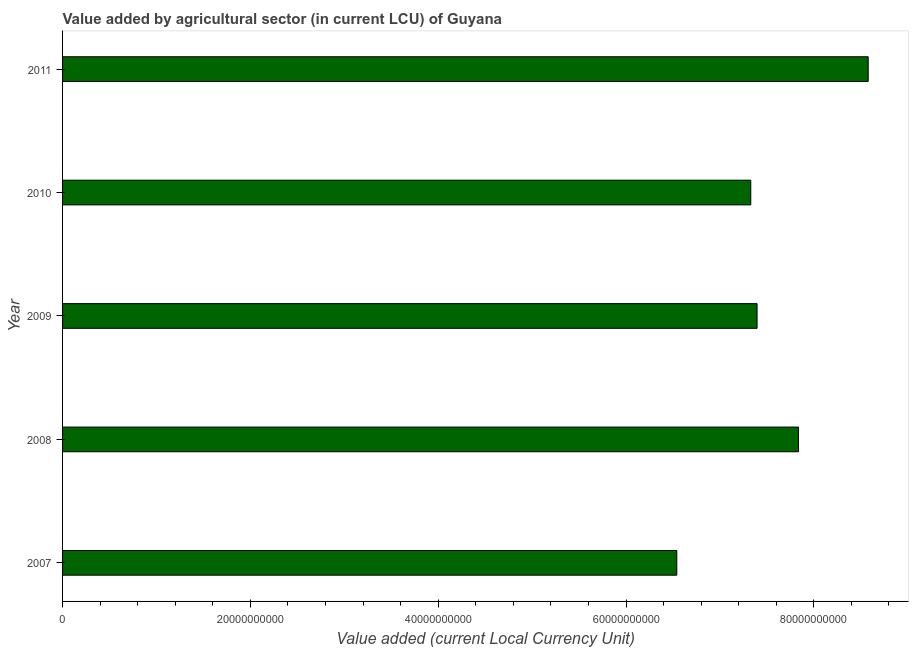Does the graph contain any zero values?
Give a very brief answer. No. Does the graph contain grids?
Offer a very short reply. No. What is the title of the graph?
Offer a very short reply. Value added by agricultural sector (in current LCU) of Guyana. What is the label or title of the X-axis?
Give a very brief answer. Value added (current Local Currency Unit). What is the label or title of the Y-axis?
Your answer should be very brief. Year. What is the value added by agriculture sector in 2011?
Keep it short and to the point. 8.58e+1. Across all years, what is the maximum value added by agriculture sector?
Your response must be concise. 8.58e+1. Across all years, what is the minimum value added by agriculture sector?
Make the answer very short. 6.54e+1. In which year was the value added by agriculture sector maximum?
Make the answer very short. 2011. What is the sum of the value added by agriculture sector?
Give a very brief answer. 3.77e+11. What is the difference between the value added by agriculture sector in 2007 and 2008?
Make the answer very short. -1.30e+1. What is the average value added by agriculture sector per year?
Make the answer very short. 7.54e+1. What is the median value added by agriculture sector?
Offer a terse response. 7.40e+1. In how many years, is the value added by agriculture sector greater than 84000000000 LCU?
Provide a short and direct response. 1. Do a majority of the years between 2009 and 2007 (inclusive) have value added by agriculture sector greater than 24000000000 LCU?
Provide a succinct answer. Yes. What is the ratio of the value added by agriculture sector in 2010 to that in 2011?
Offer a very short reply. 0.85. Is the difference between the value added by agriculture sector in 2007 and 2009 greater than the difference between any two years?
Offer a very short reply. No. What is the difference between the highest and the second highest value added by agriculture sector?
Provide a succinct answer. 7.42e+09. What is the difference between the highest and the lowest value added by agriculture sector?
Your answer should be very brief. 2.04e+1. Are all the bars in the graph horizontal?
Keep it short and to the point. Yes. What is the difference between two consecutive major ticks on the X-axis?
Offer a very short reply. 2.00e+1. What is the Value added (current Local Currency Unit) in 2007?
Your answer should be very brief. 6.54e+1. What is the Value added (current Local Currency Unit) in 2008?
Give a very brief answer. 7.84e+1. What is the Value added (current Local Currency Unit) of 2009?
Make the answer very short. 7.40e+1. What is the Value added (current Local Currency Unit) in 2010?
Offer a terse response. 7.33e+1. What is the Value added (current Local Currency Unit) in 2011?
Your answer should be compact. 8.58e+1. What is the difference between the Value added (current Local Currency Unit) in 2007 and 2008?
Offer a terse response. -1.30e+1. What is the difference between the Value added (current Local Currency Unit) in 2007 and 2009?
Provide a succinct answer. -8.55e+09. What is the difference between the Value added (current Local Currency Unit) in 2007 and 2010?
Provide a succinct answer. -7.88e+09. What is the difference between the Value added (current Local Currency Unit) in 2007 and 2011?
Provide a succinct answer. -2.04e+1. What is the difference between the Value added (current Local Currency Unit) in 2008 and 2009?
Offer a very short reply. 4.41e+09. What is the difference between the Value added (current Local Currency Unit) in 2008 and 2010?
Your answer should be compact. 5.08e+09. What is the difference between the Value added (current Local Currency Unit) in 2008 and 2011?
Your answer should be very brief. -7.42e+09. What is the difference between the Value added (current Local Currency Unit) in 2009 and 2010?
Provide a short and direct response. 6.71e+08. What is the difference between the Value added (current Local Currency Unit) in 2009 and 2011?
Your answer should be very brief. -1.18e+1. What is the difference between the Value added (current Local Currency Unit) in 2010 and 2011?
Make the answer very short. -1.25e+1. What is the ratio of the Value added (current Local Currency Unit) in 2007 to that in 2008?
Provide a short and direct response. 0.83. What is the ratio of the Value added (current Local Currency Unit) in 2007 to that in 2009?
Offer a very short reply. 0.88. What is the ratio of the Value added (current Local Currency Unit) in 2007 to that in 2010?
Keep it short and to the point. 0.89. What is the ratio of the Value added (current Local Currency Unit) in 2007 to that in 2011?
Provide a short and direct response. 0.76. What is the ratio of the Value added (current Local Currency Unit) in 2008 to that in 2009?
Offer a terse response. 1.06. What is the ratio of the Value added (current Local Currency Unit) in 2008 to that in 2010?
Your response must be concise. 1.07. What is the ratio of the Value added (current Local Currency Unit) in 2009 to that in 2010?
Keep it short and to the point. 1.01. What is the ratio of the Value added (current Local Currency Unit) in 2009 to that in 2011?
Offer a very short reply. 0.86. What is the ratio of the Value added (current Local Currency Unit) in 2010 to that in 2011?
Give a very brief answer. 0.85. 